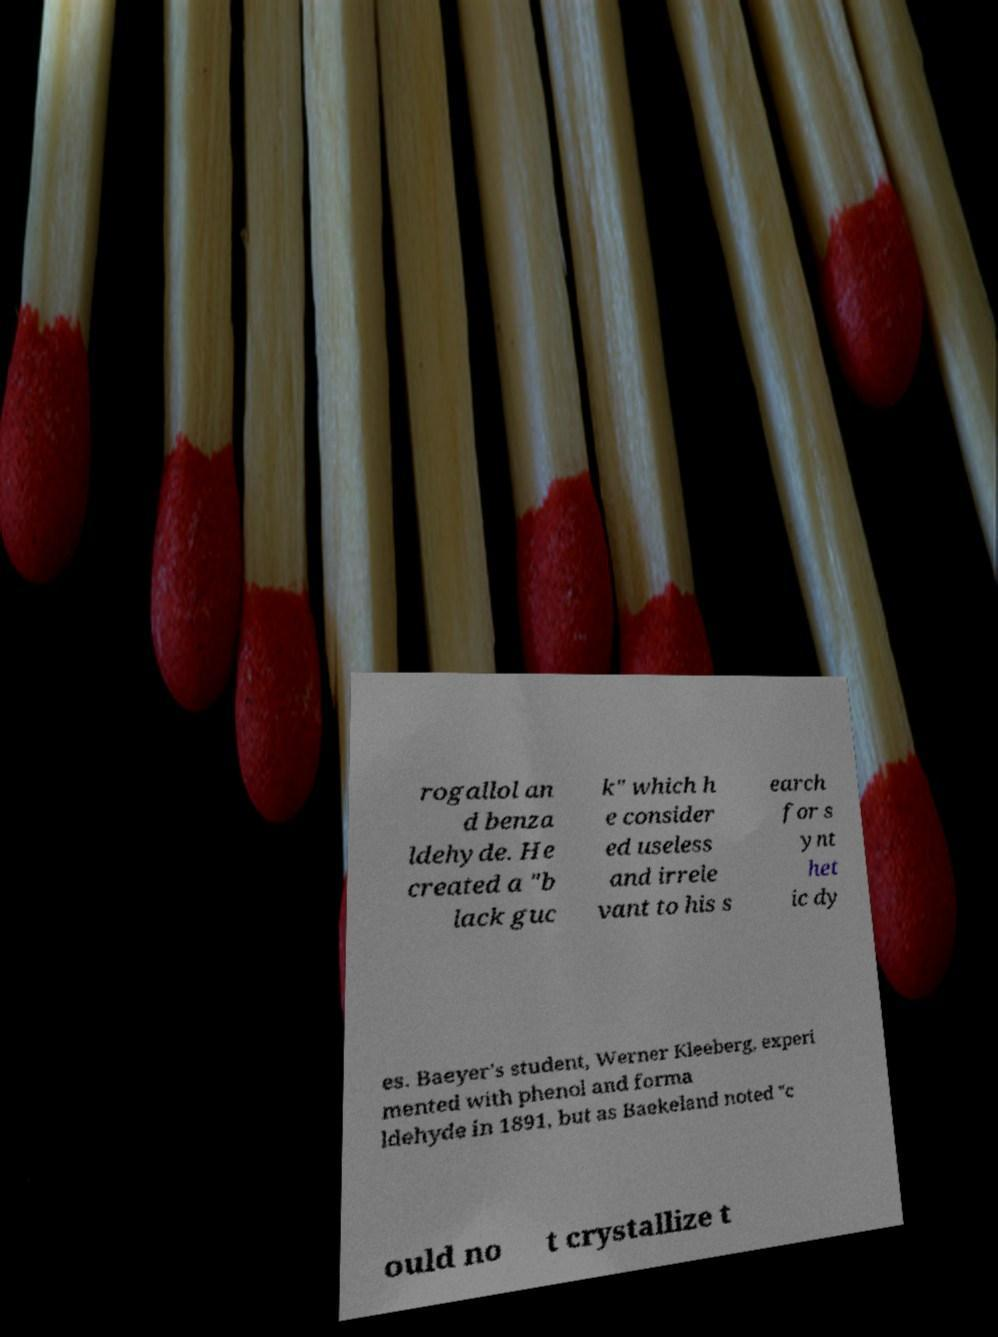Can you read and provide the text displayed in the image?This photo seems to have some interesting text. Can you extract and type it out for me? rogallol an d benza ldehyde. He created a "b lack guc k" which h e consider ed useless and irrele vant to his s earch for s ynt het ic dy es. Baeyer's student, Werner Kleeberg, experi mented with phenol and forma ldehyde in 1891, but as Baekeland noted "c ould no t crystallize t 